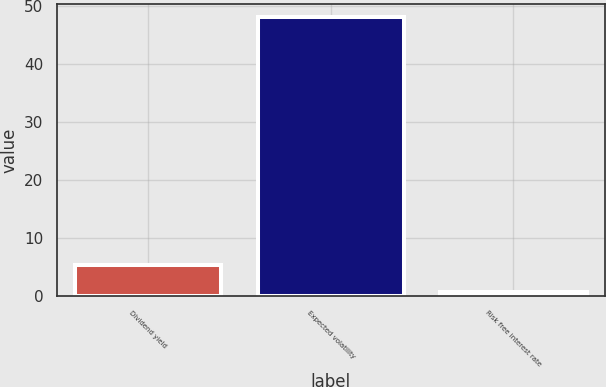Convert chart to OTSL. <chart><loc_0><loc_0><loc_500><loc_500><bar_chart><fcel>Dividend yield<fcel>Expected volatility<fcel>Risk free interest rate<nl><fcel>5.48<fcel>48.1<fcel>0.74<nl></chart> 